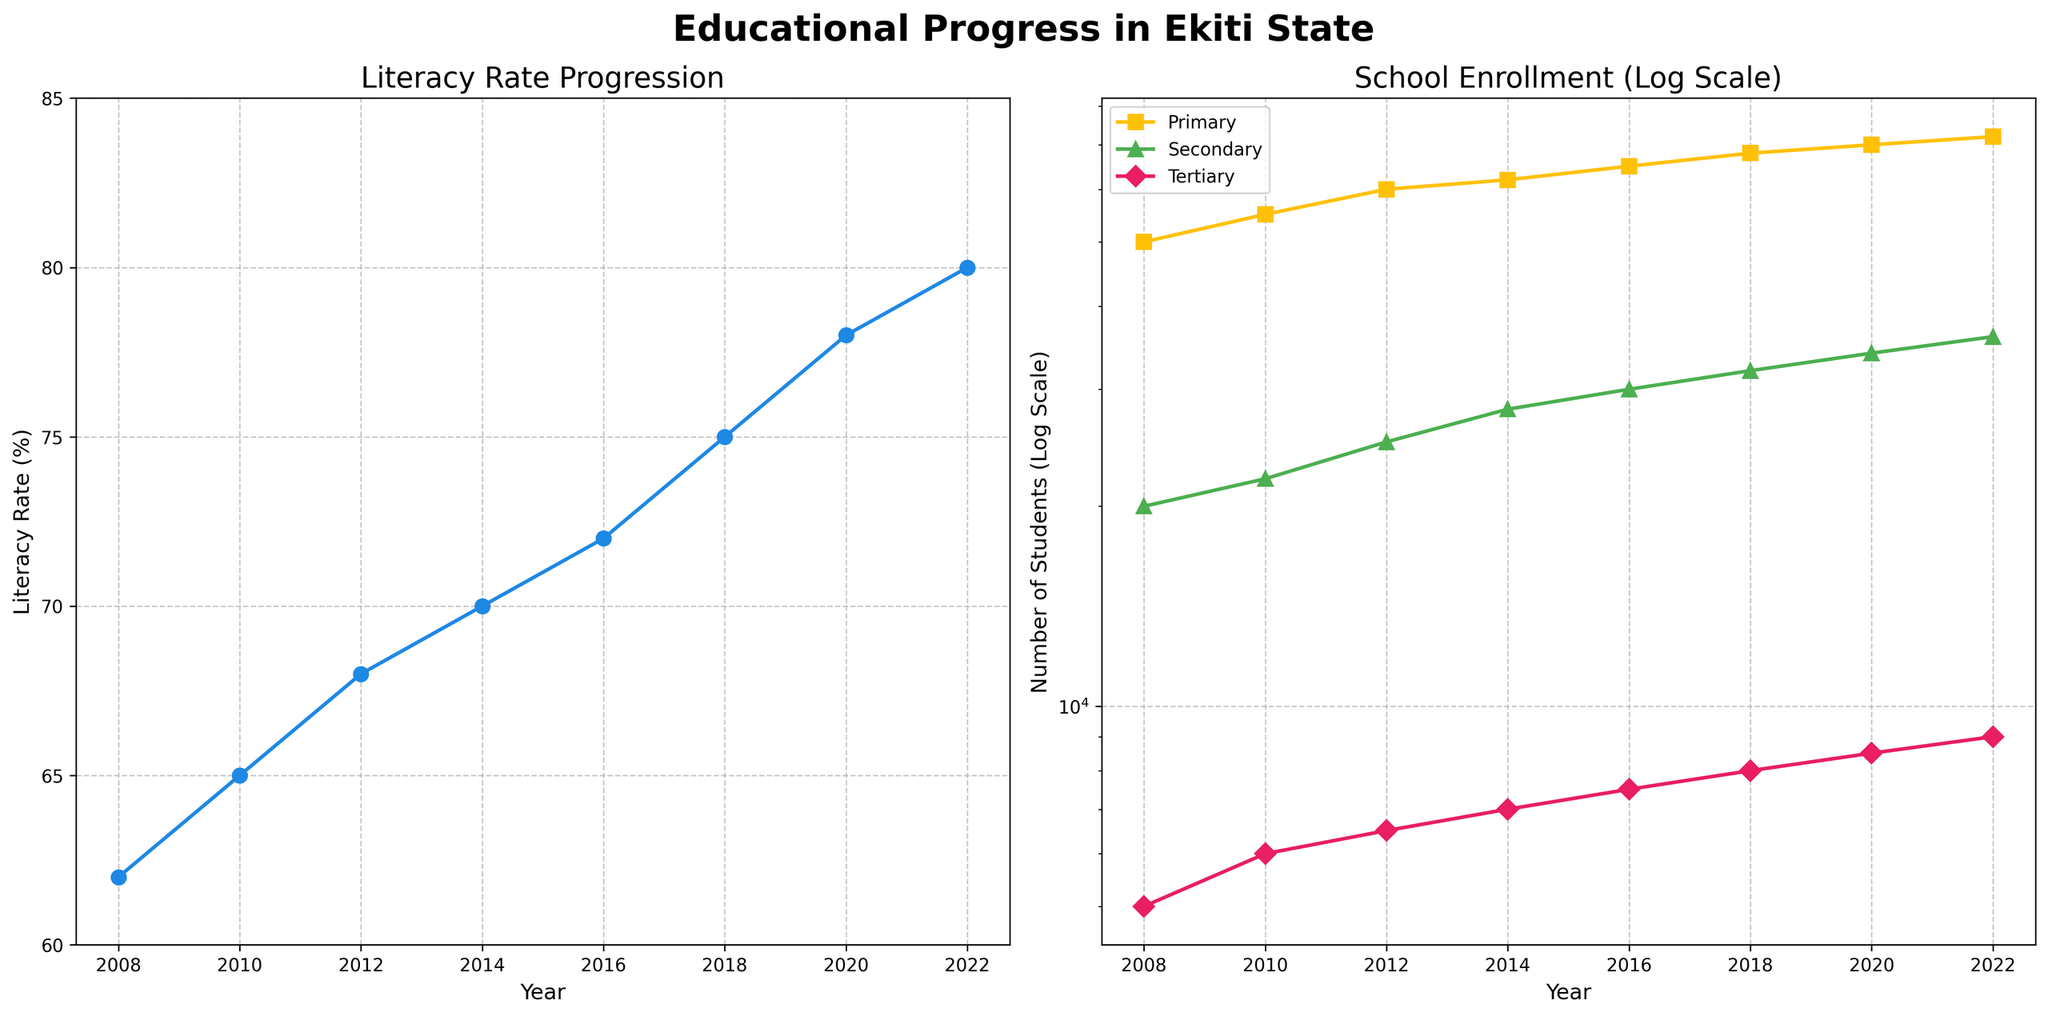How many years of data are represented in the plot? The x-axis of both subplots shows data points corresponding to the years listed (2008, 2010, 2012, 2014, 2016, 2018, 2020, 2022), giving a total of 8 years.
Answer: 8 Which year has the highest literacy rate? By observing the plot of Literacy Rate Progression (left subplot), the highest data point is at the year 2022 with a literacy rate of 80%.
Answer: 2022 Compare the Secondary School Enrollment between 2008 and 2018. From the right subplot, the Secondary School Enrollment in 2008 is 20,000 while in 2018 it is 32,000. 32,000 - 20,000 = 12,000 which means there is an increase of 12,000 students.
Answer: 12,000 Was there a year when both Primary and Secondary School Enrollment had a similar number of students? From the right subplot, clearly observing both curves (semi-logarithmic scale) there does not seem to be a year where these values are close; Primary School Enrollment is always significantly higher.
Answer: No What is the overall trend of the Tertiary School Enrollment from 2008 to 2022? The right subplot indicates a consistent rise from 5,000 in 2008 to 9,000 in 2022 for Tertiary School Enrollment.
Answer: Increasing Which type of school enrollment has the smallest value in 2008? Referring to the right subplot, Tertiary School Enrollment had the smallest value of 5,000 compared to Primary (50,000) and Secondary School (20,000) Enrollment.
Answer: Tertiary School Enrollment Calculate the average literacy rate over the years presented. Add up all the literacy rates (62 + 65 + 68 + 70 + 72 + 75 + 78 + 80) = 570. Divide this sum by the number of years (570/8).
Answer: 71.25% Between 2010 and 2016, which school level saw the largest increase in enrollment? By calculating the differences for each school level: Primary (65,000 - 55,000 = 10,000), Secondary (30,000 - 22,000 = 8,000), Tertiary (7,500 - 6,000 = 1,500). The largest increase is in Primary School Enrollment of 10,000.
Answer: Primary School Enrollment How does the literacy rate progression compare to Tertiary School Enrollment between 2008 and 2014? Comparing the left subplot and Tertiary School Enrollment on the right subplot, the literacy rate increased by 8% (70% - 62%) and Tertiary enrollment increased by 2,000 (7,000 - 5,000). Both show growth but literacy rate grew by 8 percentage points whereas Tertiary enrollment grew by a smaller margin in student numbers.
Answer: Both grew, literacy by 8%, Tertiary by 2,000 students Why is the y-axis of the enrollment subplot on a logarithmic scale? Using a logarithmic scale on the y-axis makes it easier to compare different magnitudes of enrollment numbers (Primary, Secondary, Tertiary) because the values differ greatly and a standard linear scale would not be as effective in showing these differences clearly.
Answer: To better compare different magnitudes of data 